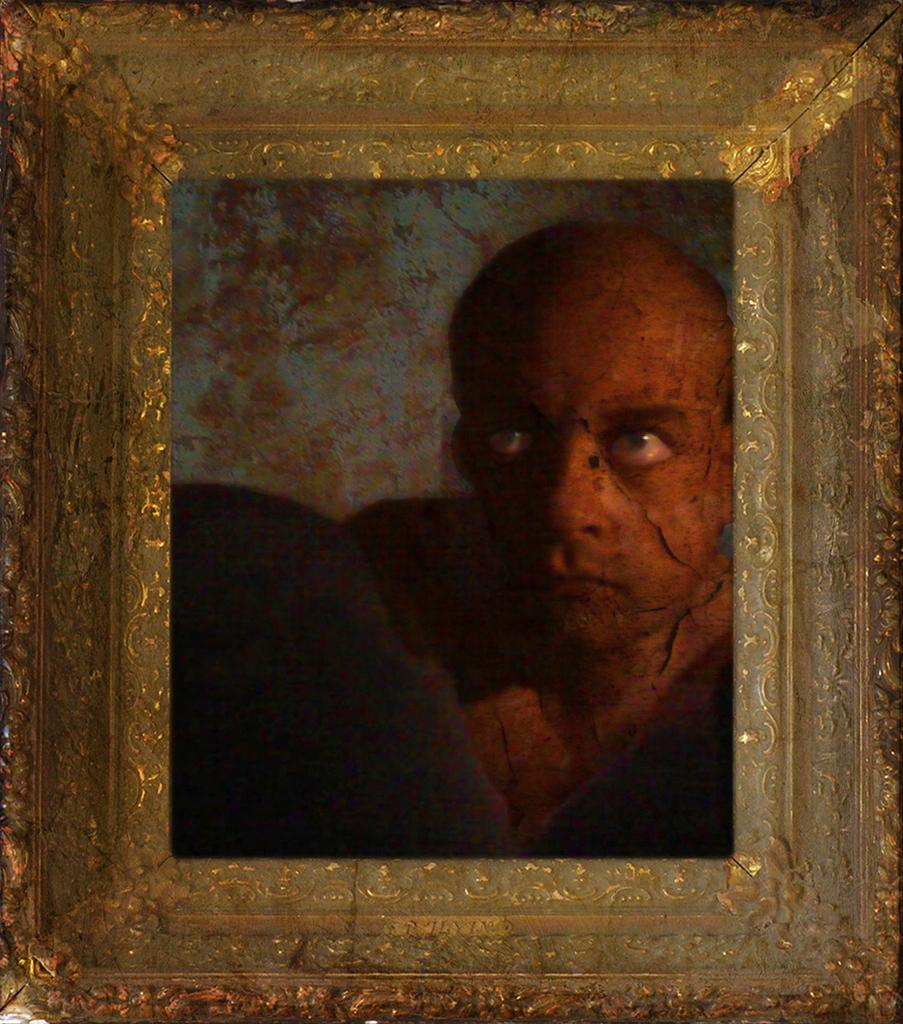What is the main object in the image? There is a frame in the image. What is inside the frame? The frame contains a person's photograph. Where is the chair located in the image? There is no chair present in the image. Can you see any wires or cables in the image? There is no mention of wires or cables in the image. Is there a squirrel visible in the image? There is no squirrel present in the image. 